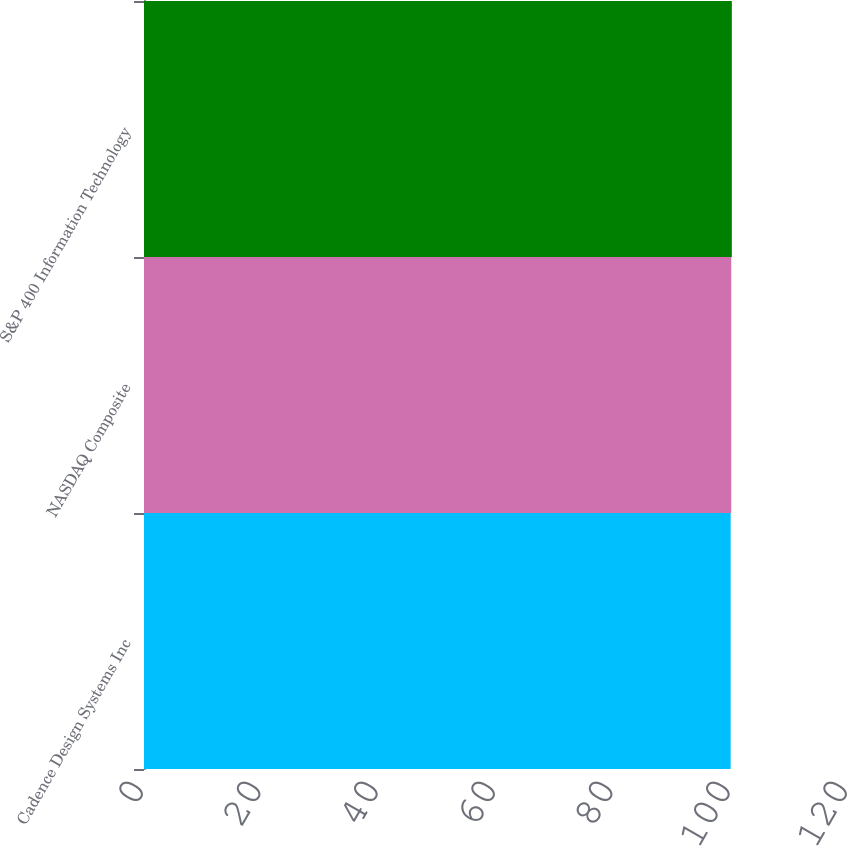Convert chart. <chart><loc_0><loc_0><loc_500><loc_500><bar_chart><fcel>Cadence Design Systems Inc<fcel>NASDAQ Composite<fcel>S&P 400 Information Technology<nl><fcel>100<fcel>100.1<fcel>100.2<nl></chart> 